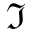Convert formula to latex. <formula><loc_0><loc_0><loc_500><loc_500>\Im</formula> 